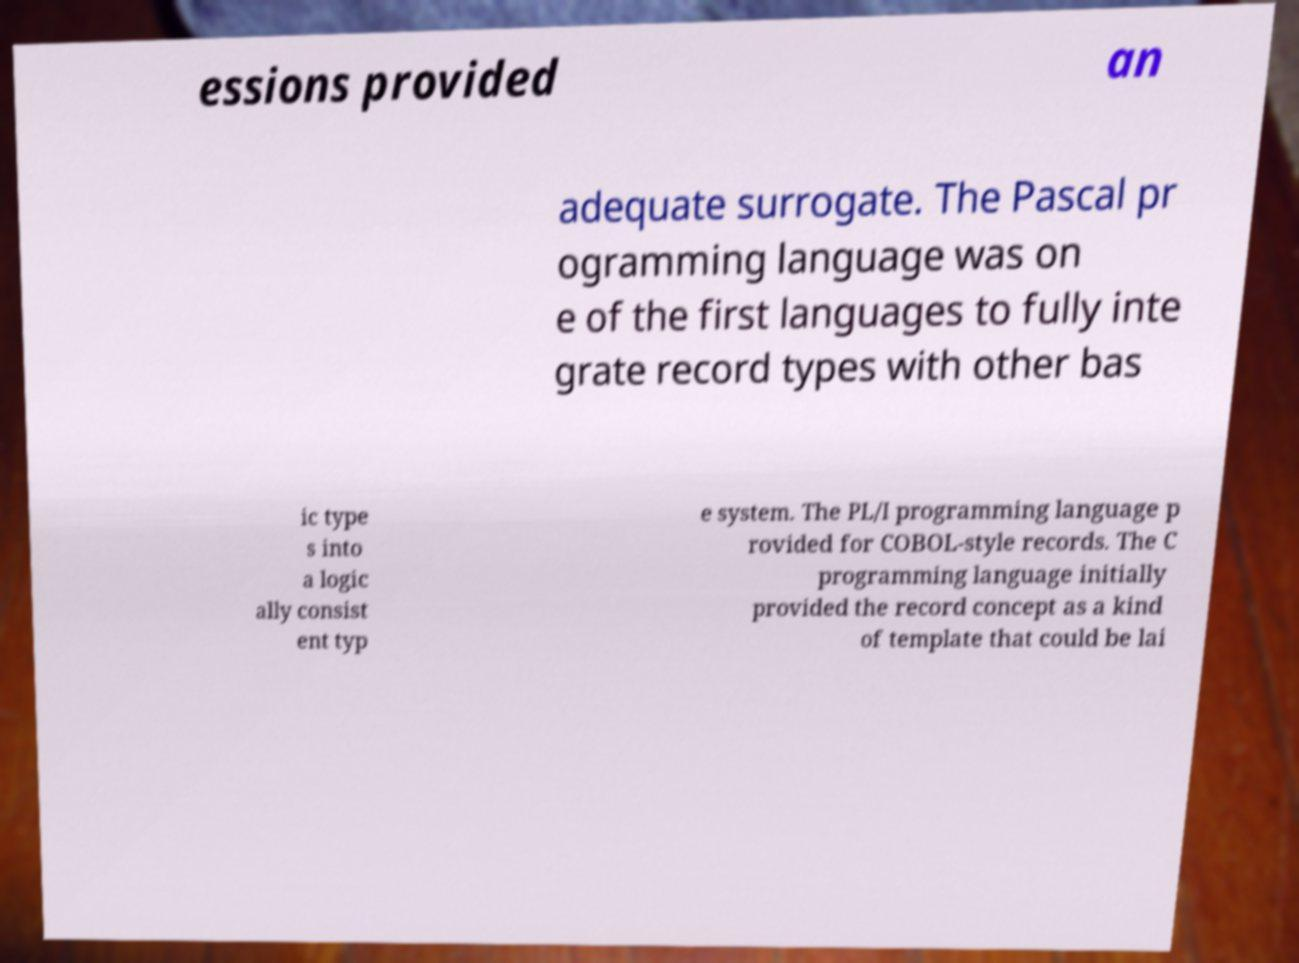I need the written content from this picture converted into text. Can you do that? essions provided an adequate surrogate. The Pascal pr ogramming language was on e of the first languages to fully inte grate record types with other bas ic type s into a logic ally consist ent typ e system. The PL/I programming language p rovided for COBOL-style records. The C programming language initially provided the record concept as a kind of template that could be lai 